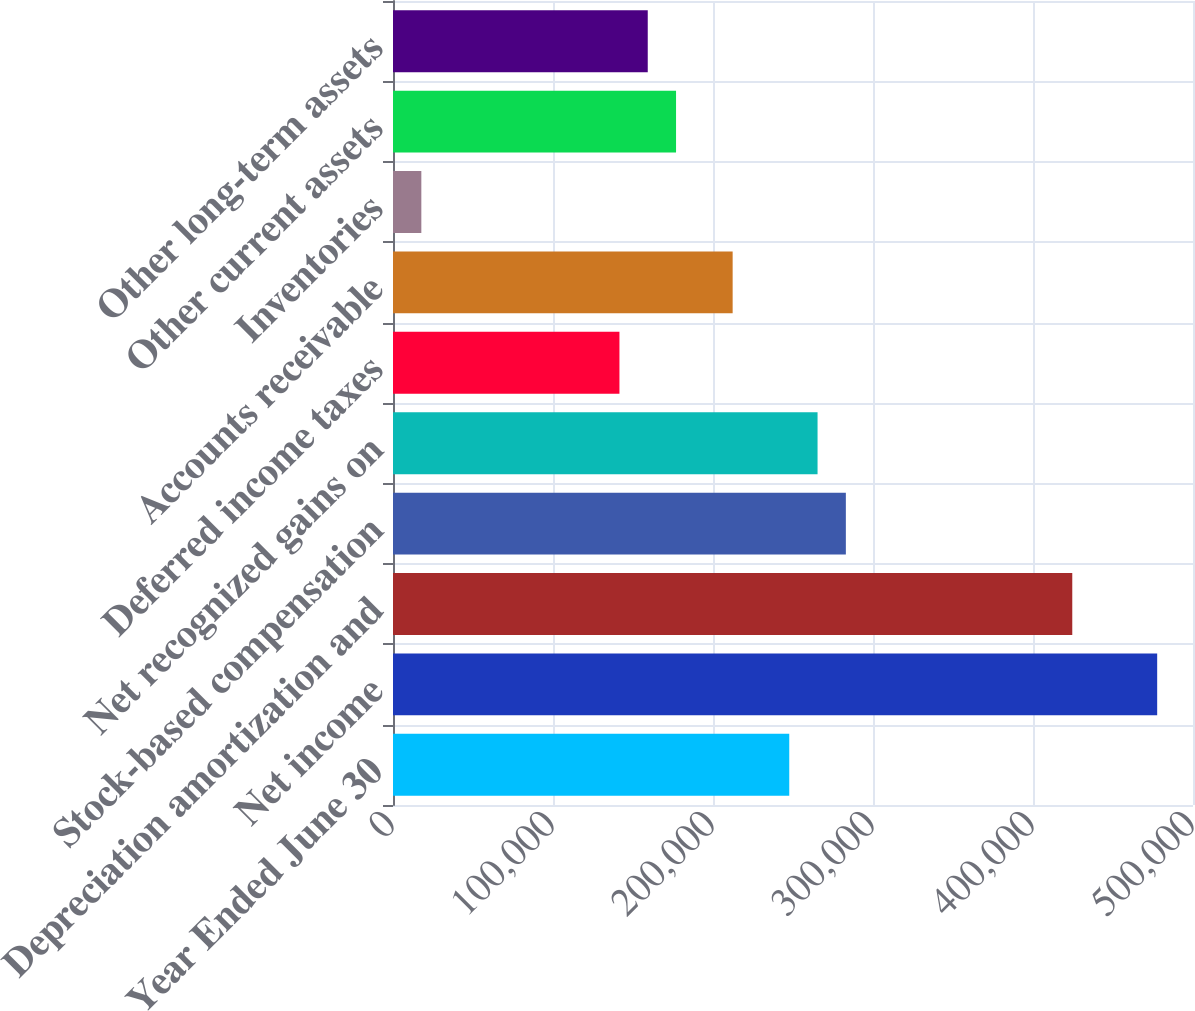Convert chart. <chart><loc_0><loc_0><loc_500><loc_500><bar_chart><fcel>Year Ended June 30<fcel>Net income<fcel>Depreciation amortization and<fcel>Stock-based compensation<fcel>Net recognized gains on<fcel>Deferred income taxes<fcel>Accounts receivable<fcel>Inventories<fcel>Other current assets<fcel>Other long-term assets<nl><fcel>247659<fcel>477611<fcel>424545<fcel>283037<fcel>265348<fcel>141528<fcel>212282<fcel>17707.6<fcel>176905<fcel>159216<nl></chart> 